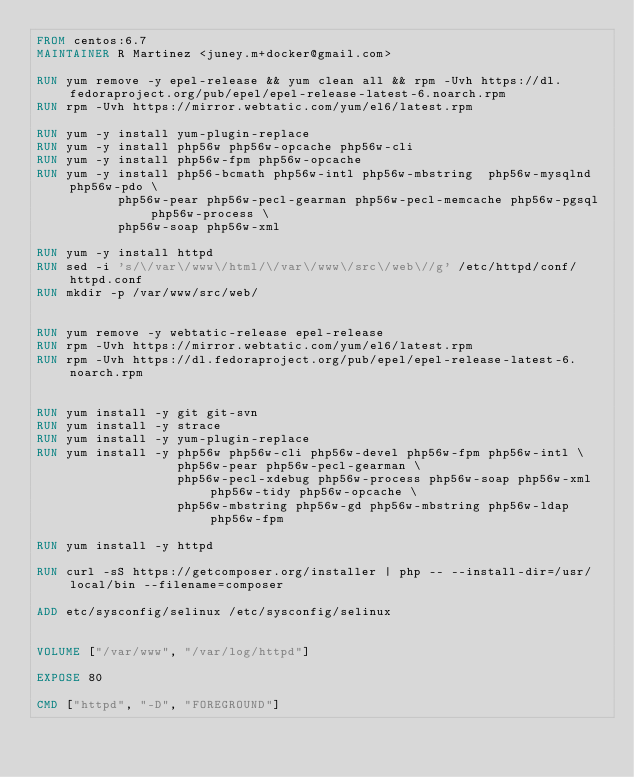Convert code to text. <code><loc_0><loc_0><loc_500><loc_500><_Dockerfile_>FROM centos:6.7
MAINTAINER R Martinez <juney.m+docker@gmail.com>

RUN yum remove -y epel-release && yum clean all && rpm -Uvh https://dl.fedoraproject.org/pub/epel/epel-release-latest-6.noarch.rpm
RUN rpm -Uvh https://mirror.webtatic.com/yum/el6/latest.rpm

RUN yum -y install yum-plugin-replace
RUN yum -y install php56w php56w-opcache php56w-cli
RUN yum -y install php56w-fpm php56w-opcache
RUN yum -y install php56-bcmath php56w-intl php56w-mbstring  php56w-mysqlnd php56w-pdo \
           php56w-pear php56w-pecl-gearman php56w-pecl-memcache php56w-pgsql php56w-process \ 
           php56w-soap php56w-xml

RUN yum -y install httpd
RUN sed -i 's/\/var\/www\/html/\/var\/www\/src\/web\//g' /etc/httpd/conf/httpd.conf
RUN mkdir -p /var/www/src/web/


RUN yum remove -y webtatic-release epel-release
RUN rpm -Uvh https://mirror.webtatic.com/yum/el6/latest.rpm
RUN rpm -Uvh https://dl.fedoraproject.org/pub/epel/epel-release-latest-6.noarch.rpm


RUN yum install -y git git-svn
RUN yum install -y strace
RUN yum install -y yum-plugin-replace
RUN yum install -y php56w php56w-cli php56w-devel php56w-fpm php56w-intl \
                   php56w-pear php56w-pecl-gearman \
                   php56w-pecl-xdebug php56w-process php56w-soap php56w-xml php56w-tidy php56w-opcache \
                   php56w-mbstring php56w-gd php56w-mbstring php56w-ldap php56w-fpm

RUN yum install -y httpd

RUN curl -sS https://getcomposer.org/installer | php -- --install-dir=/usr/local/bin --filename=composer

ADD etc/sysconfig/selinux /etc/sysconfig/selinux


VOLUME ["/var/www", "/var/log/httpd"]

EXPOSE 80

CMD ["httpd", "-D", "FOREGROUND"]
</code> 